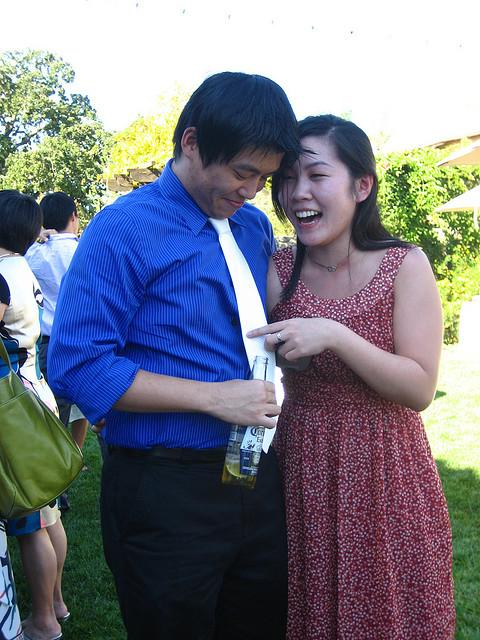How are the two people related? married 